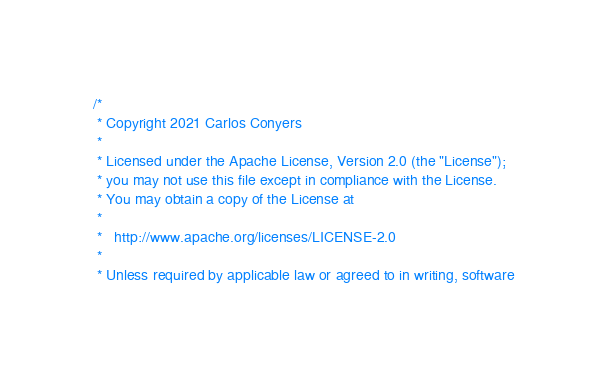Convert code to text. <code><loc_0><loc_0><loc_500><loc_500><_Scala_>/*
 * Copyright 2021 Carlos Conyers
 *
 * Licensed under the Apache License, Version 2.0 (the "License");
 * you may not use this file except in compliance with the License.
 * You may obtain a copy of the License at
 *
 *   http://www.apache.org/licenses/LICENSE-2.0
 *
 * Unless required by applicable law or agreed to in writing, software</code> 